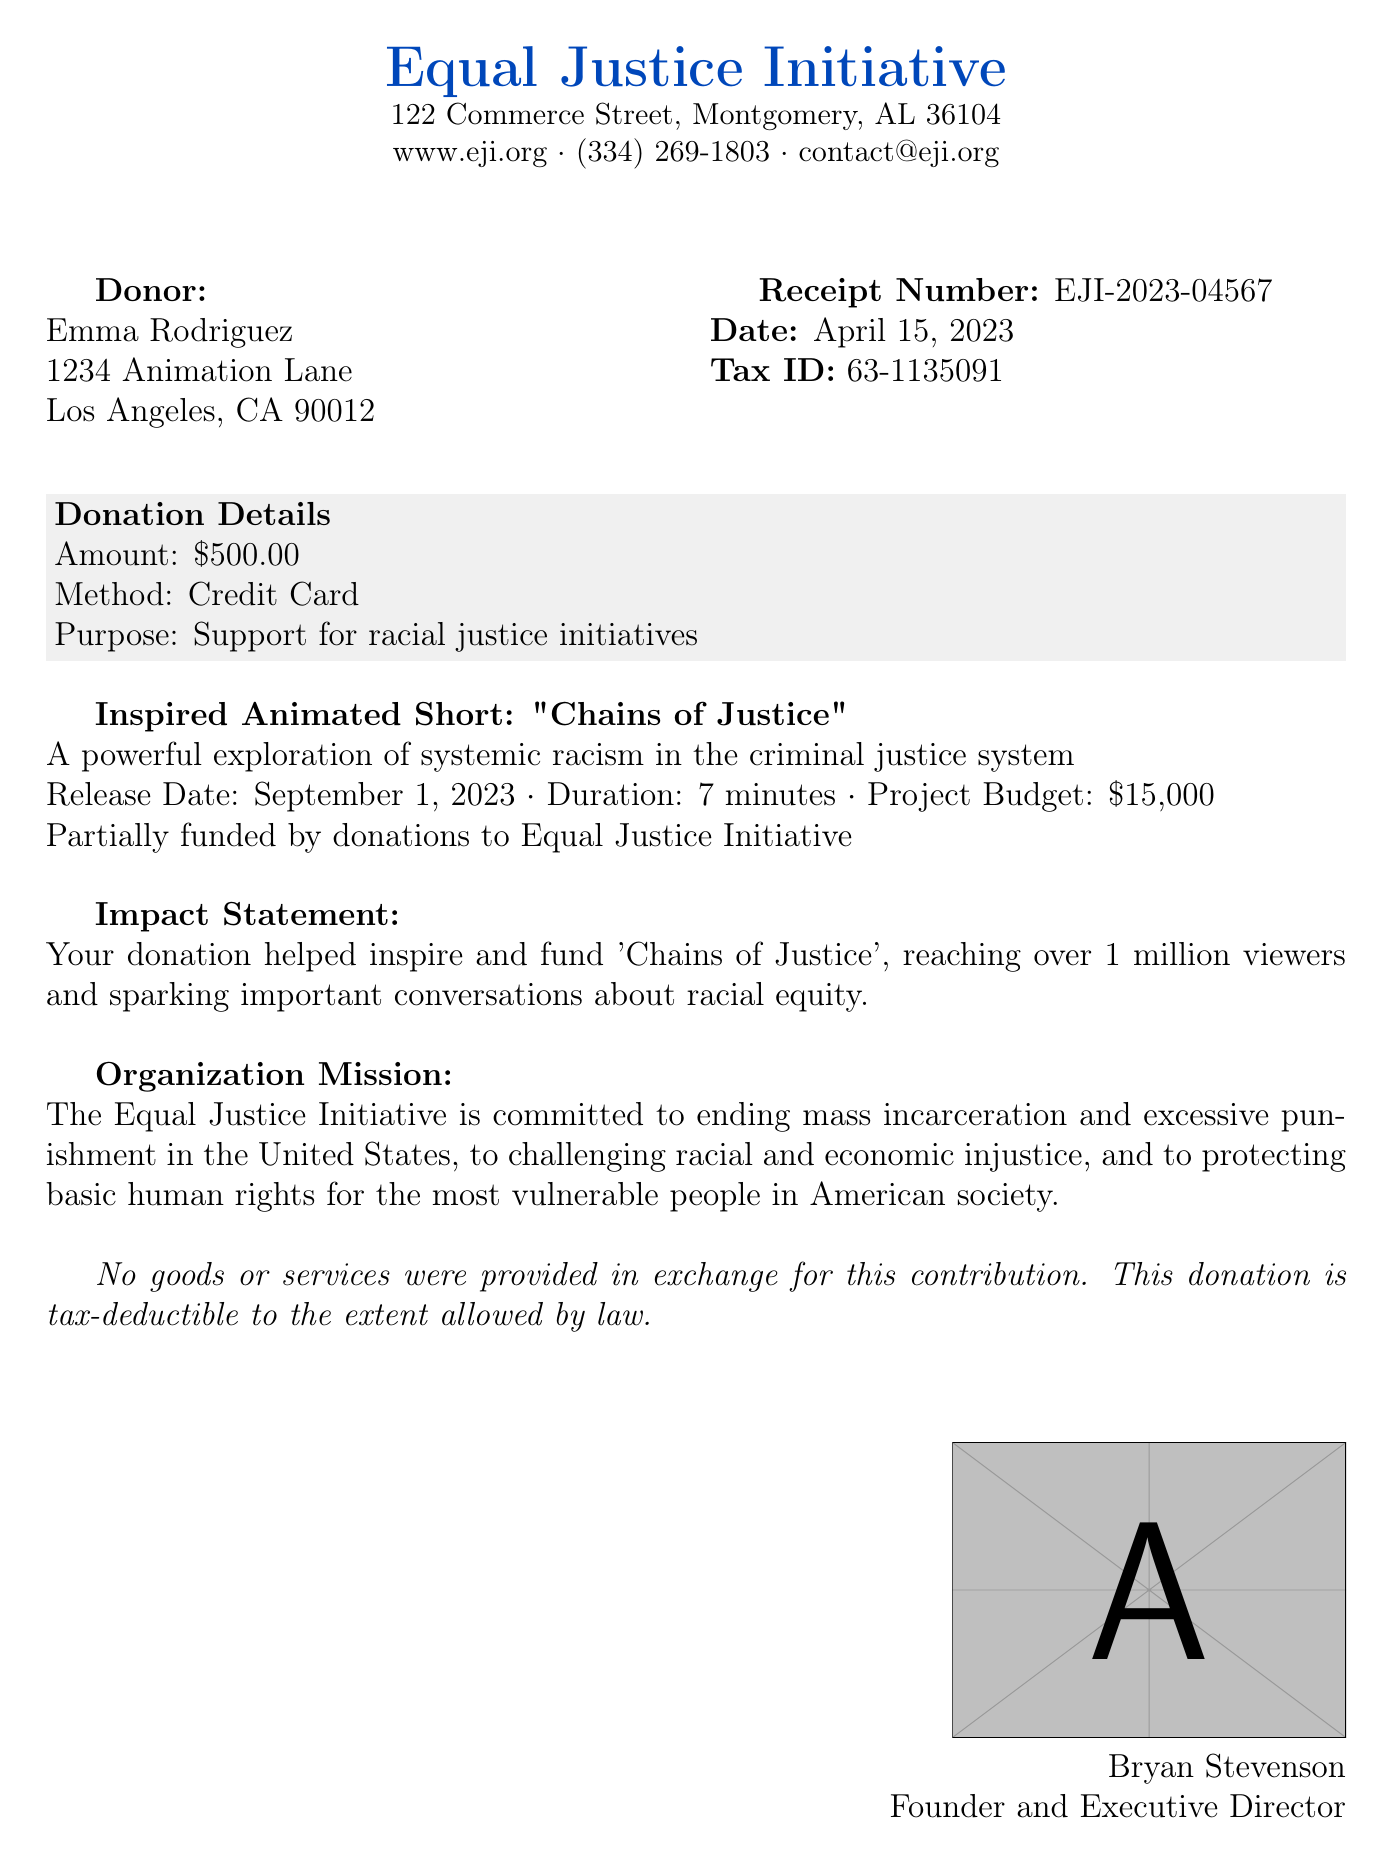What is the name of the organization? The organization name is mentioned at the top of the receipt as "Equal Justice Initiative."
Answer: Equal Justice Initiative What is the donation amount? The donation amount is specified in the donation details section of the receipt.
Answer: $500.00 Who is the donor? The donor's name is indicated in the section labeled "Donor."
Answer: Emma Rodriguez When was the donation made? The date of donation is provided beneath the receipt number.
Answer: April 15, 2023 What is the purpose of the donation? The purpose of the donation is described in the donation details section.
Answer: Support for racial justice initiatives What is the impact statement regarding the animated short? The impact statement reflects how the donation contributed to the animated short's success.
Answer: Your donation helped inspire and fund 'Chains of Justice', reaching over 1 million viewers and sparking important conversations about racial equity What is the tax ID number? The tax ID number is a specific identifier provided on the receipt.
Answer: 63-1135091 Who signed the receipt? The document includes a signature section for the organization’s leader.
Answer: Bryan Stevenson What is the release date of the animated short? The release date of the animated short is mentioned in the details about "Chains of Justice."
Answer: September 1, 2023 What is the mission of the organization? The organization's mission is described in a specific section of the document.
Answer: The Equal Justice Initiative is committed to ending mass incarceration and excessive punishment in the United States, to challenging racial and economic injustice, and to protecting basic human rights for the most vulnerable people in American society 